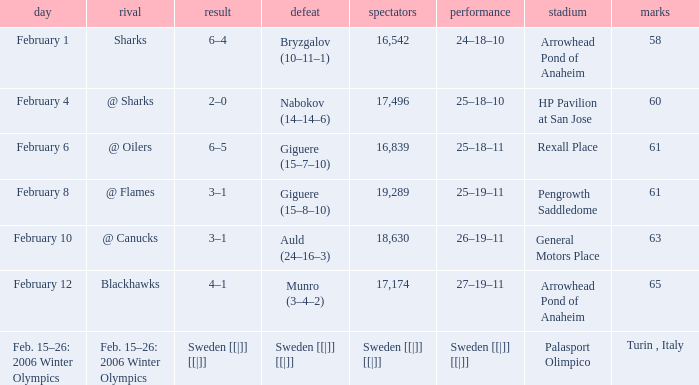What is the points when the score was 3–1, and record was 25–19–11? 61.0. 